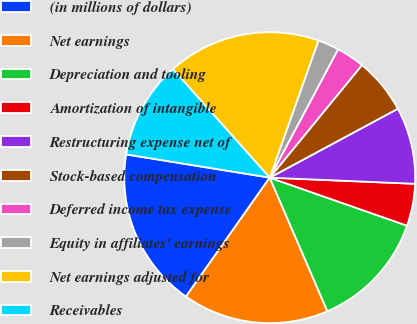Convert chart. <chart><loc_0><loc_0><loc_500><loc_500><pie_chart><fcel>(in millions of dollars)<fcel>Net earnings<fcel>Depreciation and tooling<fcel>Amortization of intangible<fcel>Restructuring expense net of<fcel>Stock-based compensation<fcel>Deferred income tax expense<fcel>Equity in affiliates' earnings<fcel>Net earnings adjusted for<fcel>Receivables<nl><fcel>17.79%<fcel>16.25%<fcel>13.16%<fcel>4.68%<fcel>8.53%<fcel>6.22%<fcel>3.14%<fcel>2.36%<fcel>17.02%<fcel>10.85%<nl></chart> 